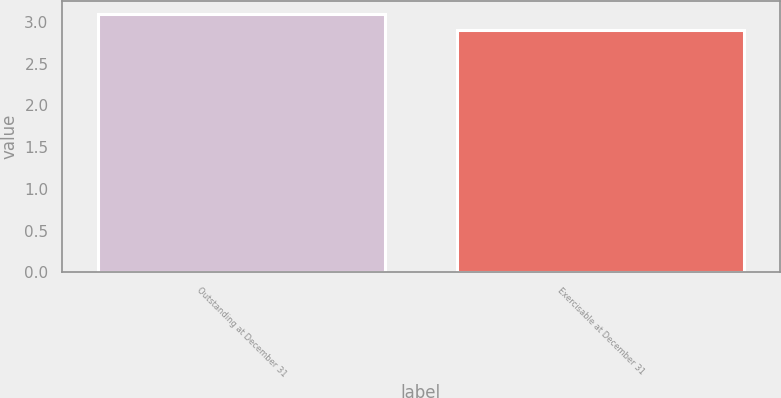<chart> <loc_0><loc_0><loc_500><loc_500><bar_chart><fcel>Outstanding at December 31<fcel>Exercisable at December 31<nl><fcel>3.1<fcel>2.9<nl></chart> 